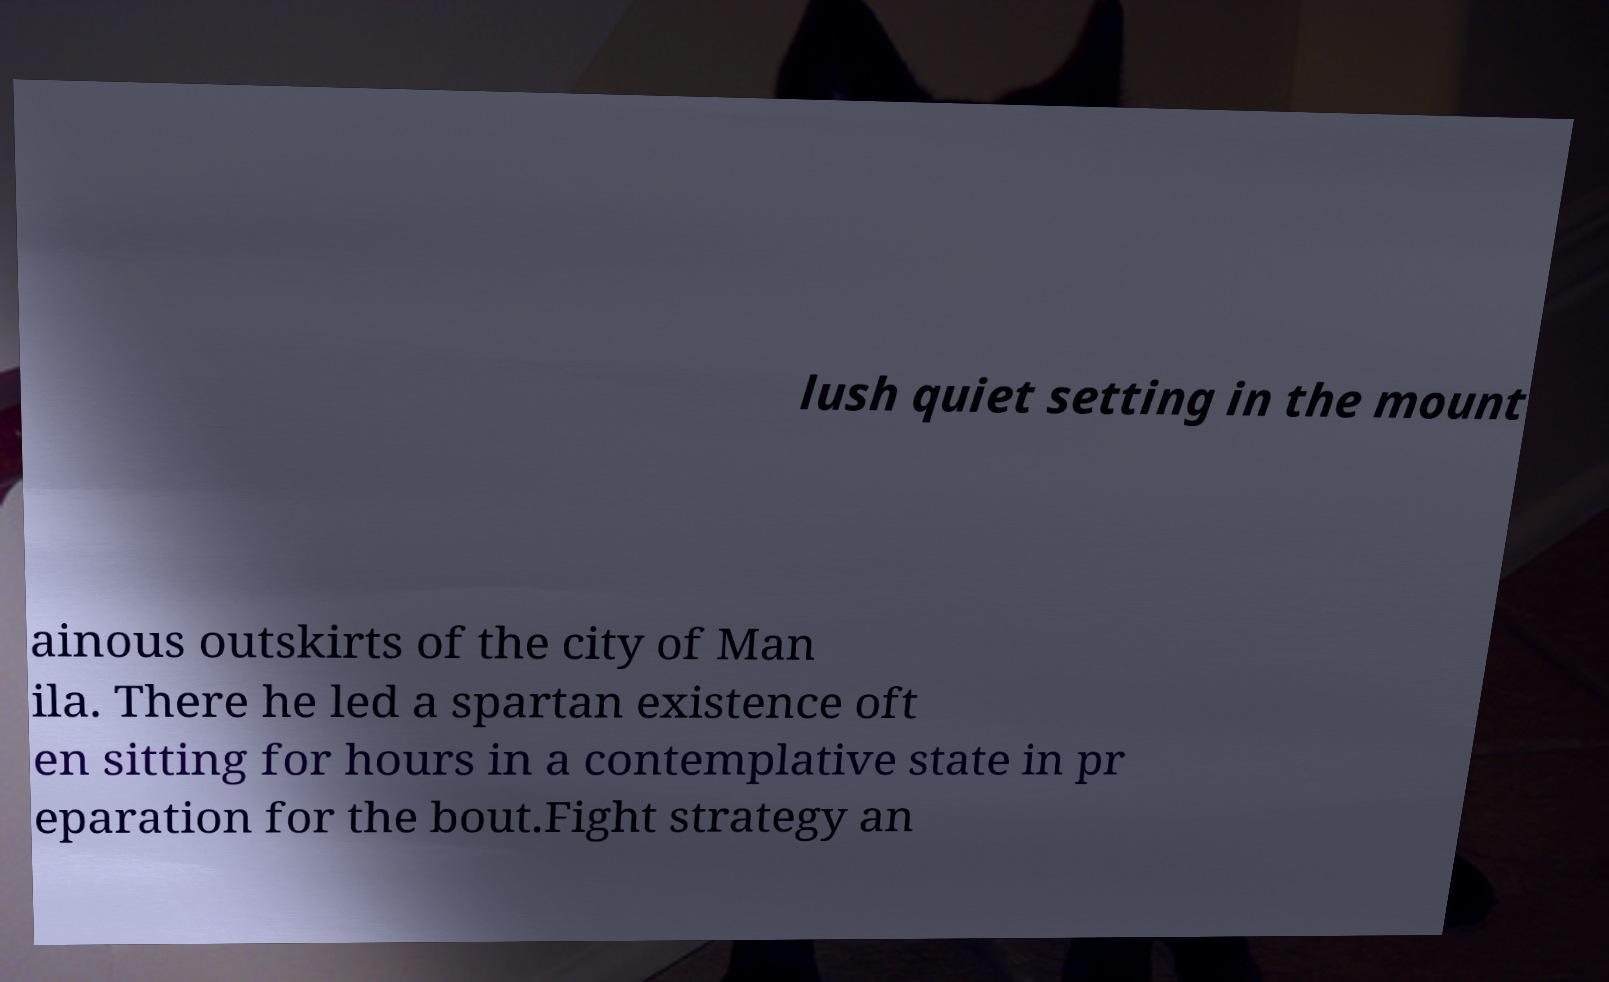Please identify and transcribe the text found in this image. lush quiet setting in the mount ainous outskirts of the city of Man ila. There he led a spartan existence oft en sitting for hours in a contemplative state in pr eparation for the bout.Fight strategy an 